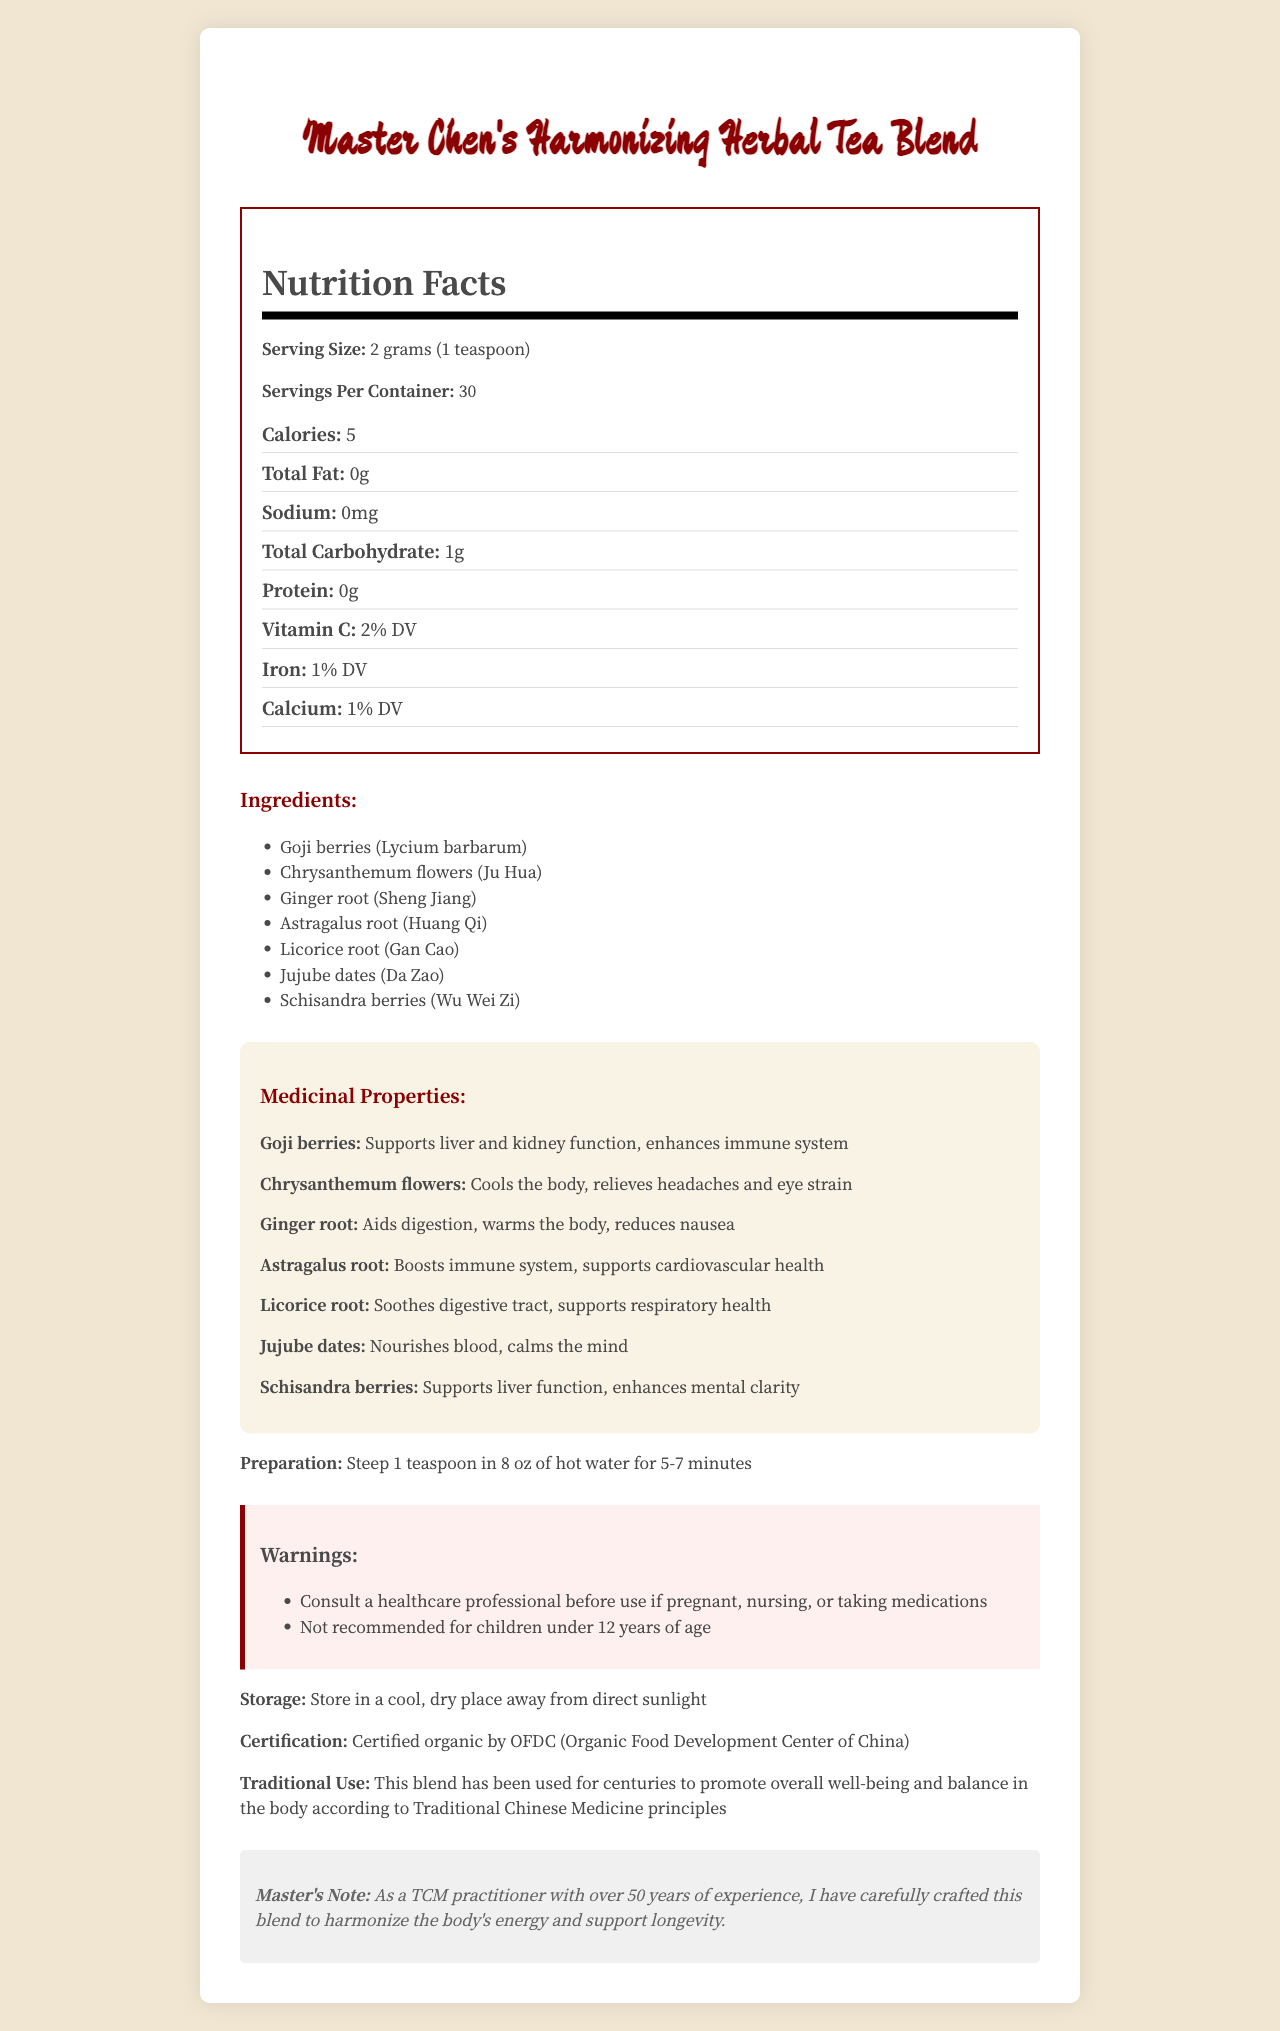What is the serving size of Master Chen's Harmonizing Herbal Tea Blend? The document states the serving size directly in the Nutrition Facts section.
Answer: 2 grams (1 teaspoon) How many servings are there per container? The Nutrition Facts section lists the number of servings per container as 30.
Answer: 30 How many calories does one serving of this tea blend contain? According to the Nutrition Facts, there are 5 calories per serving.
Answer: 5 Which ingredient is known to cool the body and relieve headaches and eye strain? The Medicinal Properties section states that Chrysanthemum flowers cool the body and relieve headaches and eye strain.
Answer: Chrysanthemum flowers (Ju Hua) What is the recommended steeping time for this herbal tea? The Preparation section advises to steep the tea for 5-7 minutes.
Answer: 5-7 minutes What is the percentage daily value (% DV) of Vitamin C in one serving of the tea blend? The Nutrition Facts section shows that one serving provides 2% of the daily value of Vitamin C.
Answer: 2% Which of the following ingredients supports liver function? 
A. Goji berries 
B. Schisandra berries 
C. Astragalus root The Medicinal Properties section states that Schisandra berries support liver function.
Answer: B Which vitamin or mineral is present at 1% daily value in this tea blend? 
i. Vitamin C 
ii. Iron 
iii. Calcium Both Iron and Calcium are listed at 1% daily value, but the question specifies a single option, hence the answer can validly be either one, but Iron is shown first.
Answer: ii Is this tea recommended for children under 12 years of age? The warnings section states that it is not recommended for children under 12 years of age.
Answer: No Does this tea blend contain any protein? The Nutrition Facts section shows that there is no protein in one serving.
Answer: No Summarize the document describing the main idea. The document provides detailed information about the nutritional content, ingredients, medicinal benefits, preparation, warnings, storage, certification, and traditional use of the herbal tea blend.
Answer: Master Chen's Harmonizing Herbal Tea Blend is a traditional Chinese herbal tea that combines multiple herbs known for their beneficial health properties. The tea is low in calories, with notable ingredients including Goji berries, Chrysanthemum flowers, and Ginger root. Each herb has specific medicinal properties, such as enhancing the immune system, cooling the body, or aiding digestion. It is certified organic and recommended for promoting overall well-being. Instructions for preparation and warnings are also provided. Is this tea blend certified organic? The certification section states that it is certified organic by the OFDC (Organic Food Development Center of China).
Answer: Yes What benefit is associated with Astragalus root in the tea blend? The Medicinal Properties section lists these benefits for Astragalus root.
Answer: Boosts immune system, supports cardiovascular health Who crafted this herbal tea blend? The Master's Note at the end of the document indicates that Master Chen, a practitioner with over 50 years of experience, crafted the blend.
Answer: Master Chen Where should the tea be stored? The Storage section advises on the proper storage conditions for the tea.
Answer: In a cool, dry place away from direct sunlight What other benefits, apart from supporting liver function, does Schisandra berries provide? The Medicinal Properties section lists enhancing mental clarity and supporting liver function as benefits of Schisandra berries.
Answer: Enhances mental clarity Can we determine the exact number of carbohydrates in one serving from the visual document? The document does not specify the exact number of carbohydrates, just that it totals to 1 gram, which could include sugars and other carbohydrates. Therefore, we cannot determine the precise breakdown.
Answer: No 